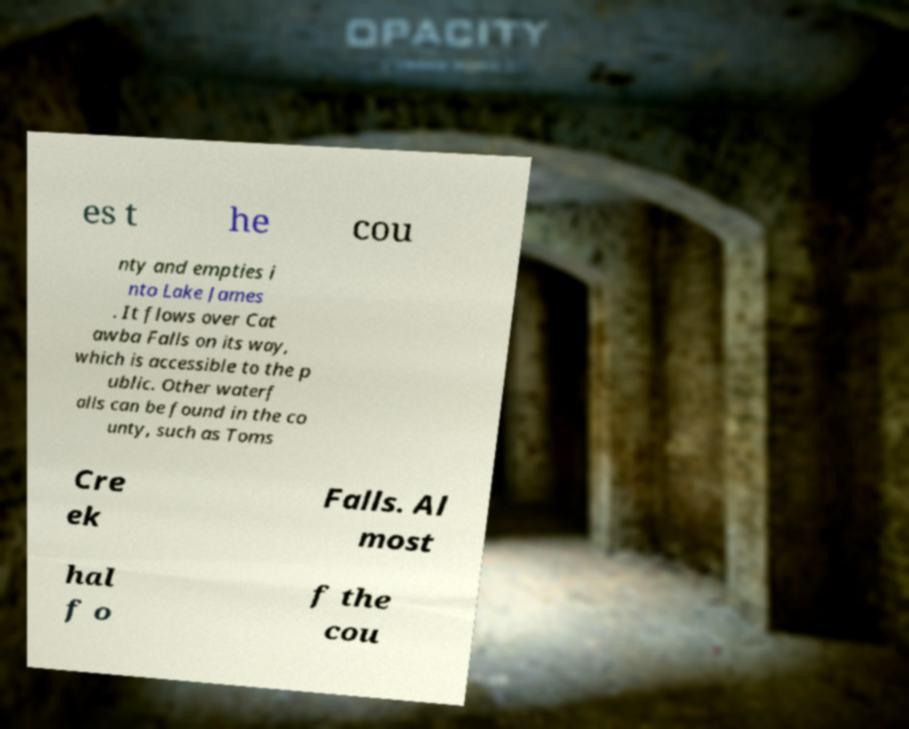What messages or text are displayed in this image? I need them in a readable, typed format. es t he cou nty and empties i nto Lake James . It flows over Cat awba Falls on its way, which is accessible to the p ublic. Other waterf alls can be found in the co unty, such as Toms Cre ek Falls. Al most hal f o f the cou 